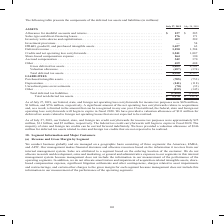According to Cisco Systems's financial document, What was the company's federal net operating loss carryforwards for income tax purposes in 2019? According to the financial document, $676 million. The relevant text states: "ng loss carryforwards for income tax purposes were $676 million, $1 billion, and $756 million, respectively. A significant amount of the net operating loss carryfo..." Also, What was the Sales-type and direct-financing leases in 2019? According to the financial document, 176 (in millions). The relevant text states: "27 $ 285 Sales-type and direct-financing leases . 176 171 Inventory write-downs and capitalization. . 409 289 Investment provisions . — 54 IPR&D, goodwil..." Also, What was the depreciation in 2018? According to the financial document, (118) (in millions). The relevant text states: "ngible assets. . (705) (753) Depreciation. . (141) (118) Unrealized gains on investments. . (70) (33) Other . (112) (145) Total deferred tax liabilities. . (..." Also, can you calculate: What was the change in Share-based compensation expense between 2018 and 2019? Based on the calculation: 164-190, the result is -26 (in millions). This is based on the information: ",241 1,087 Share-based compensation expense . 164 190 Accrued compensation . 342 370 Other . 419 408 Gross deferred tax assets . 5,455 4,501 Valuation al . 1,241 1,087 Share-based compensation expense..." The key data points involved are: 164, 190. Also, can you calculate: What was the change in Accrued compensation between 2018 and 2019? Based on the calculation: 342-370, the result is -28 (in millions). This is based on the information: "ensation expense . 164 190 Accrued compensation . 342 370 Other . 419 408 Gross deferred tax assets . 5,455 4,501 Valuation allowance. . (457) (374) Tota tion expense . 164 190 Accrued compensation . ..." The key data points involved are: 342, 370. Also, can you calculate: What was the percentage change in total deferred tax assets between 2018 and 2019? To answer this question, I need to perform calculations using the financial data. The calculation is: (4,998-4,127)/4,127, which equals 21.1 (percentage). This is based on the information: "wance. . (457) (374) Total deferred tax assets. . 4,998 4,127 LIABILITIES Purchased intangible assets. . (705) (753) Depreciation. . (141) (118) Unrealized . (457) (374) Total deferred tax assets. . 4..." The key data points involved are: 4,127, 4,998. 